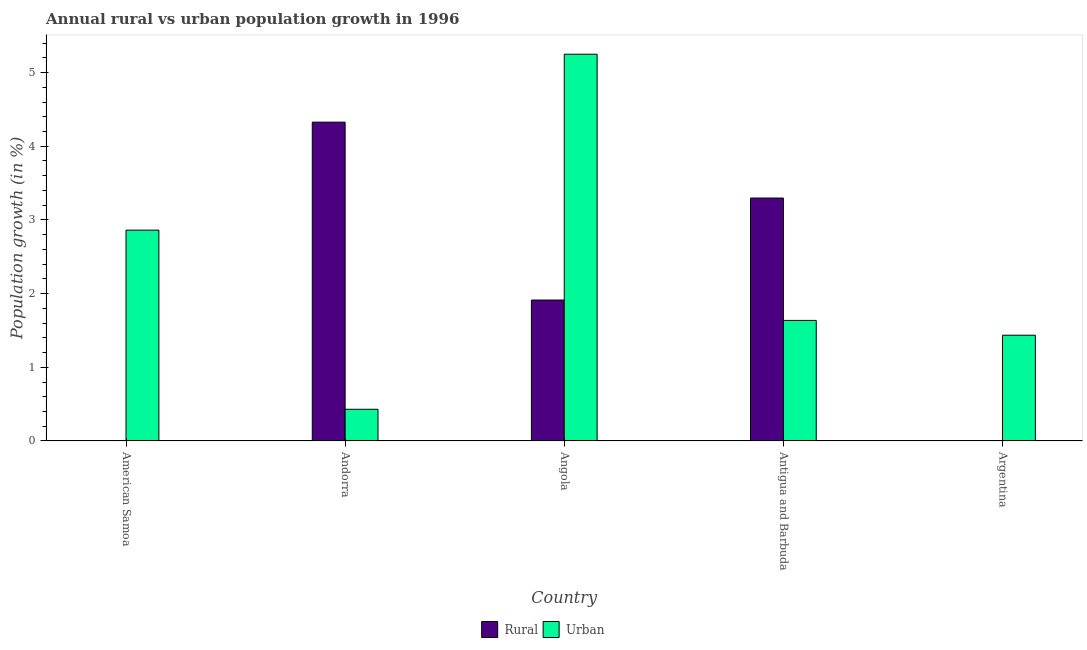What is the label of the 1st group of bars from the left?
Your answer should be compact. American Samoa. In how many cases, is the number of bars for a given country not equal to the number of legend labels?
Make the answer very short. 2. What is the rural population growth in Antigua and Barbuda?
Your answer should be compact. 3.3. Across all countries, what is the maximum rural population growth?
Offer a very short reply. 4.33. Across all countries, what is the minimum urban population growth?
Provide a succinct answer. 0.43. In which country was the urban population growth maximum?
Offer a terse response. Angola. What is the total urban population growth in the graph?
Provide a succinct answer. 11.61. What is the difference between the rural population growth in Andorra and that in Angola?
Ensure brevity in your answer.  2.41. What is the difference between the rural population growth in Argentina and the urban population growth in Antigua and Barbuda?
Make the answer very short. -1.64. What is the average rural population growth per country?
Your answer should be compact. 1.91. What is the difference between the rural population growth and urban population growth in Antigua and Barbuda?
Give a very brief answer. 1.66. In how many countries, is the urban population growth greater than 4.8 %?
Provide a short and direct response. 1. What is the ratio of the urban population growth in Andorra to that in Argentina?
Provide a succinct answer. 0.3. What is the difference between the highest and the second highest rural population growth?
Ensure brevity in your answer.  1.03. What is the difference between the highest and the lowest urban population growth?
Provide a short and direct response. 4.82. In how many countries, is the urban population growth greater than the average urban population growth taken over all countries?
Your answer should be compact. 2. How many bars are there?
Make the answer very short. 8. How many countries are there in the graph?
Provide a short and direct response. 5. Are the values on the major ticks of Y-axis written in scientific E-notation?
Offer a terse response. No. Does the graph contain any zero values?
Ensure brevity in your answer.  Yes. Does the graph contain grids?
Offer a very short reply. No. How are the legend labels stacked?
Provide a succinct answer. Horizontal. What is the title of the graph?
Your answer should be compact. Annual rural vs urban population growth in 1996. Does "External balance on goods" appear as one of the legend labels in the graph?
Your answer should be compact. No. What is the label or title of the X-axis?
Your response must be concise. Country. What is the label or title of the Y-axis?
Your answer should be compact. Population growth (in %). What is the Population growth (in %) in Rural in American Samoa?
Give a very brief answer. 0. What is the Population growth (in %) of Urban  in American Samoa?
Provide a short and direct response. 2.86. What is the Population growth (in %) in Rural in Andorra?
Ensure brevity in your answer.  4.33. What is the Population growth (in %) in Urban  in Andorra?
Offer a very short reply. 0.43. What is the Population growth (in %) in Rural in Angola?
Ensure brevity in your answer.  1.91. What is the Population growth (in %) of Urban  in Angola?
Your answer should be very brief. 5.25. What is the Population growth (in %) of Rural in Antigua and Barbuda?
Keep it short and to the point. 3.3. What is the Population growth (in %) of Urban  in Antigua and Barbuda?
Your response must be concise. 1.64. What is the Population growth (in %) in Rural in Argentina?
Your answer should be very brief. 0. What is the Population growth (in %) in Urban  in Argentina?
Offer a very short reply. 1.44. Across all countries, what is the maximum Population growth (in %) of Rural?
Keep it short and to the point. 4.33. Across all countries, what is the maximum Population growth (in %) in Urban ?
Give a very brief answer. 5.25. Across all countries, what is the minimum Population growth (in %) of Rural?
Your response must be concise. 0. Across all countries, what is the minimum Population growth (in %) of Urban ?
Your answer should be compact. 0.43. What is the total Population growth (in %) in Rural in the graph?
Offer a terse response. 9.54. What is the total Population growth (in %) of Urban  in the graph?
Your answer should be compact. 11.61. What is the difference between the Population growth (in %) of Urban  in American Samoa and that in Andorra?
Offer a terse response. 2.43. What is the difference between the Population growth (in %) in Urban  in American Samoa and that in Angola?
Offer a very short reply. -2.39. What is the difference between the Population growth (in %) in Urban  in American Samoa and that in Antigua and Barbuda?
Offer a terse response. 1.23. What is the difference between the Population growth (in %) in Urban  in American Samoa and that in Argentina?
Ensure brevity in your answer.  1.43. What is the difference between the Population growth (in %) of Rural in Andorra and that in Angola?
Give a very brief answer. 2.41. What is the difference between the Population growth (in %) in Urban  in Andorra and that in Angola?
Your response must be concise. -4.82. What is the difference between the Population growth (in %) in Rural in Andorra and that in Antigua and Barbuda?
Offer a very short reply. 1.03. What is the difference between the Population growth (in %) of Urban  in Andorra and that in Antigua and Barbuda?
Provide a succinct answer. -1.21. What is the difference between the Population growth (in %) of Urban  in Andorra and that in Argentina?
Offer a terse response. -1.01. What is the difference between the Population growth (in %) of Rural in Angola and that in Antigua and Barbuda?
Provide a succinct answer. -1.38. What is the difference between the Population growth (in %) in Urban  in Angola and that in Antigua and Barbuda?
Your response must be concise. 3.61. What is the difference between the Population growth (in %) in Urban  in Angola and that in Argentina?
Give a very brief answer. 3.81. What is the difference between the Population growth (in %) of Urban  in Antigua and Barbuda and that in Argentina?
Your answer should be compact. 0.2. What is the difference between the Population growth (in %) in Rural in Andorra and the Population growth (in %) in Urban  in Angola?
Your answer should be compact. -0.92. What is the difference between the Population growth (in %) in Rural in Andorra and the Population growth (in %) in Urban  in Antigua and Barbuda?
Your answer should be compact. 2.69. What is the difference between the Population growth (in %) in Rural in Andorra and the Population growth (in %) in Urban  in Argentina?
Provide a short and direct response. 2.89. What is the difference between the Population growth (in %) in Rural in Angola and the Population growth (in %) in Urban  in Antigua and Barbuda?
Your response must be concise. 0.28. What is the difference between the Population growth (in %) of Rural in Angola and the Population growth (in %) of Urban  in Argentina?
Your answer should be compact. 0.48. What is the difference between the Population growth (in %) in Rural in Antigua and Barbuda and the Population growth (in %) in Urban  in Argentina?
Offer a terse response. 1.86. What is the average Population growth (in %) of Rural per country?
Make the answer very short. 1.91. What is the average Population growth (in %) of Urban  per country?
Ensure brevity in your answer.  2.32. What is the difference between the Population growth (in %) of Rural and Population growth (in %) of Urban  in Andorra?
Give a very brief answer. 3.9. What is the difference between the Population growth (in %) in Rural and Population growth (in %) in Urban  in Angola?
Offer a terse response. -3.34. What is the difference between the Population growth (in %) in Rural and Population growth (in %) in Urban  in Antigua and Barbuda?
Offer a terse response. 1.66. What is the ratio of the Population growth (in %) in Urban  in American Samoa to that in Andorra?
Offer a very short reply. 6.65. What is the ratio of the Population growth (in %) in Urban  in American Samoa to that in Angola?
Your answer should be compact. 0.55. What is the ratio of the Population growth (in %) of Urban  in American Samoa to that in Antigua and Barbuda?
Offer a very short reply. 1.75. What is the ratio of the Population growth (in %) of Urban  in American Samoa to that in Argentina?
Offer a very short reply. 1.99. What is the ratio of the Population growth (in %) in Rural in Andorra to that in Angola?
Provide a short and direct response. 2.26. What is the ratio of the Population growth (in %) in Urban  in Andorra to that in Angola?
Your answer should be very brief. 0.08. What is the ratio of the Population growth (in %) of Rural in Andorra to that in Antigua and Barbuda?
Offer a terse response. 1.31. What is the ratio of the Population growth (in %) of Urban  in Andorra to that in Antigua and Barbuda?
Your response must be concise. 0.26. What is the ratio of the Population growth (in %) of Urban  in Andorra to that in Argentina?
Provide a short and direct response. 0.3. What is the ratio of the Population growth (in %) in Rural in Angola to that in Antigua and Barbuda?
Make the answer very short. 0.58. What is the ratio of the Population growth (in %) in Urban  in Angola to that in Antigua and Barbuda?
Provide a short and direct response. 3.21. What is the ratio of the Population growth (in %) in Urban  in Angola to that in Argentina?
Offer a terse response. 3.66. What is the ratio of the Population growth (in %) in Urban  in Antigua and Barbuda to that in Argentina?
Make the answer very short. 1.14. What is the difference between the highest and the second highest Population growth (in %) of Rural?
Make the answer very short. 1.03. What is the difference between the highest and the second highest Population growth (in %) in Urban ?
Provide a succinct answer. 2.39. What is the difference between the highest and the lowest Population growth (in %) of Rural?
Provide a short and direct response. 4.33. What is the difference between the highest and the lowest Population growth (in %) in Urban ?
Your answer should be compact. 4.82. 